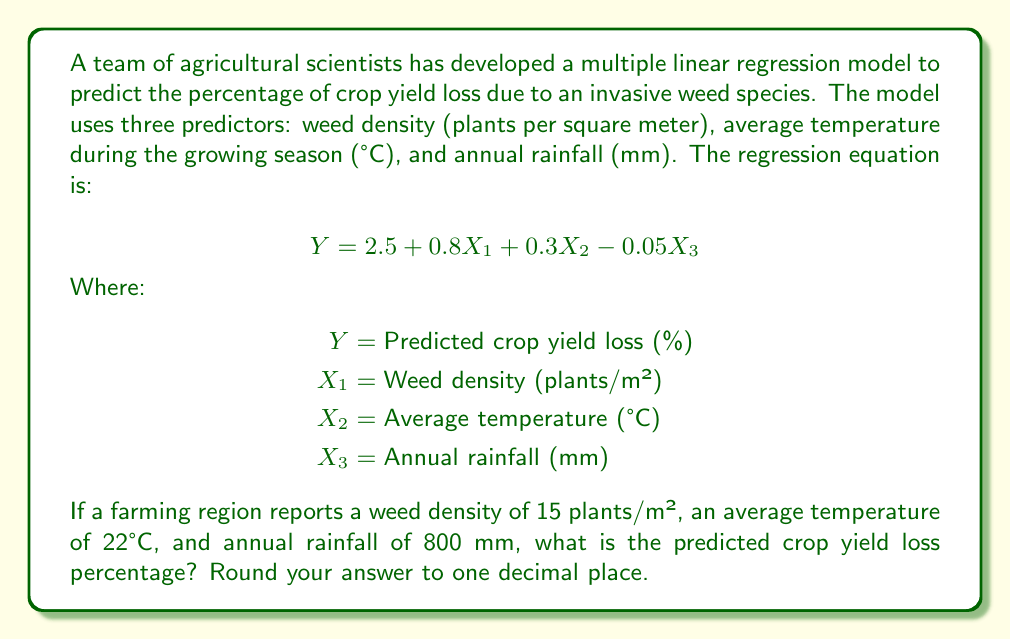Solve this math problem. To solve this problem, we need to use the given multiple linear regression equation and substitute the values for each predictor variable. Let's follow these steps:

1. Identify the values for each predictor variable:
   $X_1$ (Weed density) = 15 plants/m²
   $X_2$ (Average temperature) = 22°C
   $X_3$ (Annual rainfall) = 800 mm

2. Substitute these values into the regression equation:

   $$Y = 2.5 + 0.8X_1 + 0.3X_2 - 0.05X_3$$

3. Calculate each term:
   - Constant term: 2.5
   - Weed density term: $0.8 \times 15 = 12$
   - Temperature term: $0.3 \times 22 = 6.6$
   - Rainfall term: $-0.05 \times 800 = -40$

4. Sum all the terms:
   $$Y = 2.5 + 12 + 6.6 - 40 = -18.9$$

5. Round the result to one decimal place:
   $Y \approx -18.9\%$

The negative percentage indicates that under these specific conditions, the model predicts an increase in crop yield rather than a loss. This could be due to the high rainfall offsetting the negative impacts of weed density and temperature in this particular scenario.
Answer: -18.9% 